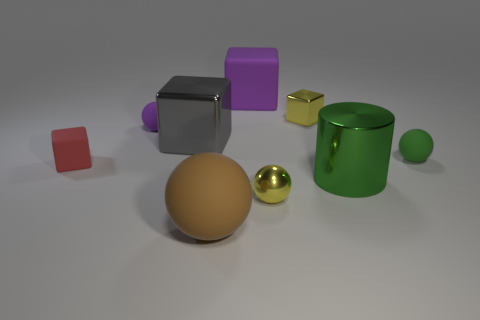Subtract all spheres. How many objects are left? 5 Subtract 0 gray cylinders. How many objects are left? 9 Subtract all tiny red cubes. Subtract all blue matte spheres. How many objects are left? 8 Add 8 tiny yellow spheres. How many tiny yellow spheres are left? 9 Add 2 tiny green balls. How many tiny green balls exist? 3 